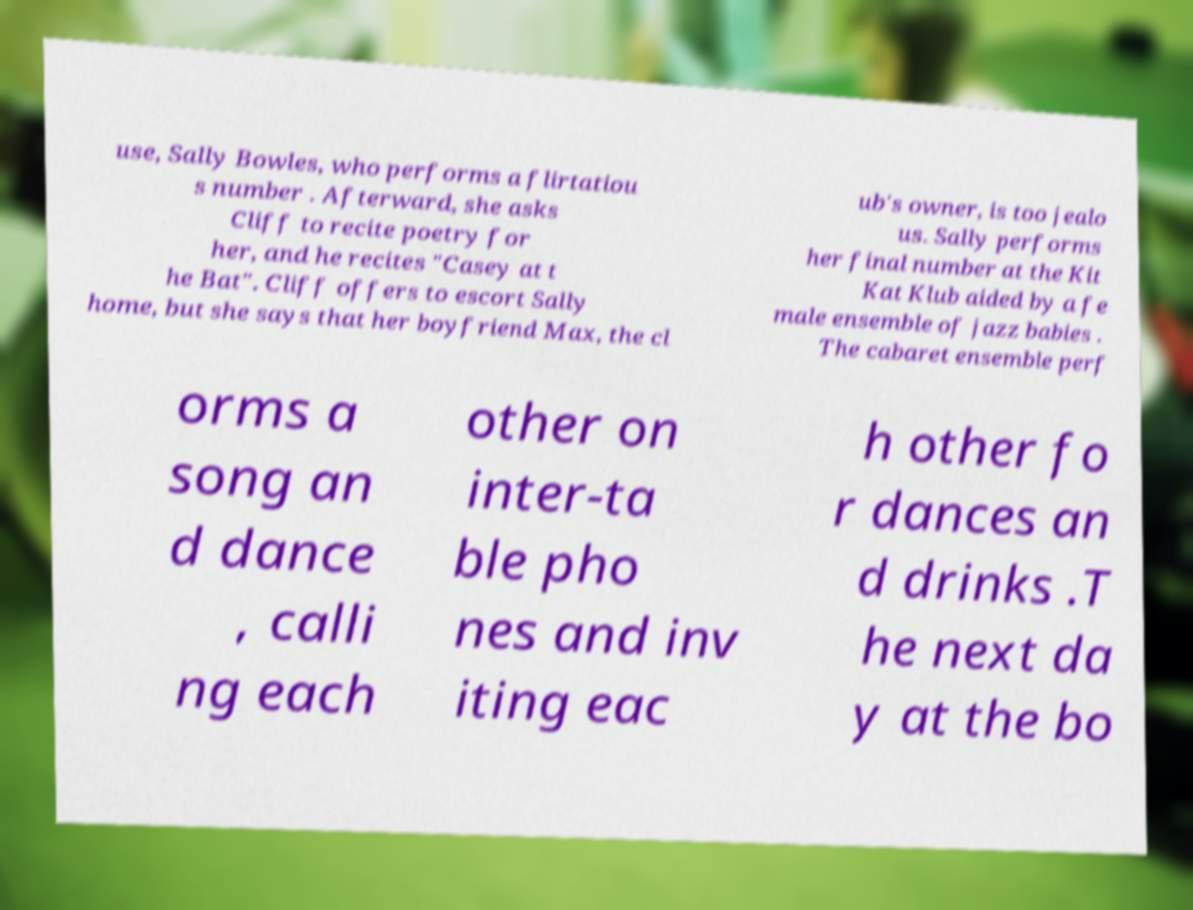There's text embedded in this image that I need extracted. Can you transcribe it verbatim? use, Sally Bowles, who performs a flirtatiou s number . Afterward, she asks Cliff to recite poetry for her, and he recites "Casey at t he Bat". Cliff offers to escort Sally home, but she says that her boyfriend Max, the cl ub's owner, is too jealo us. Sally performs her final number at the Kit Kat Klub aided by a fe male ensemble of jazz babies . The cabaret ensemble perf orms a song an d dance , calli ng each other on inter-ta ble pho nes and inv iting eac h other fo r dances an d drinks .T he next da y at the bo 